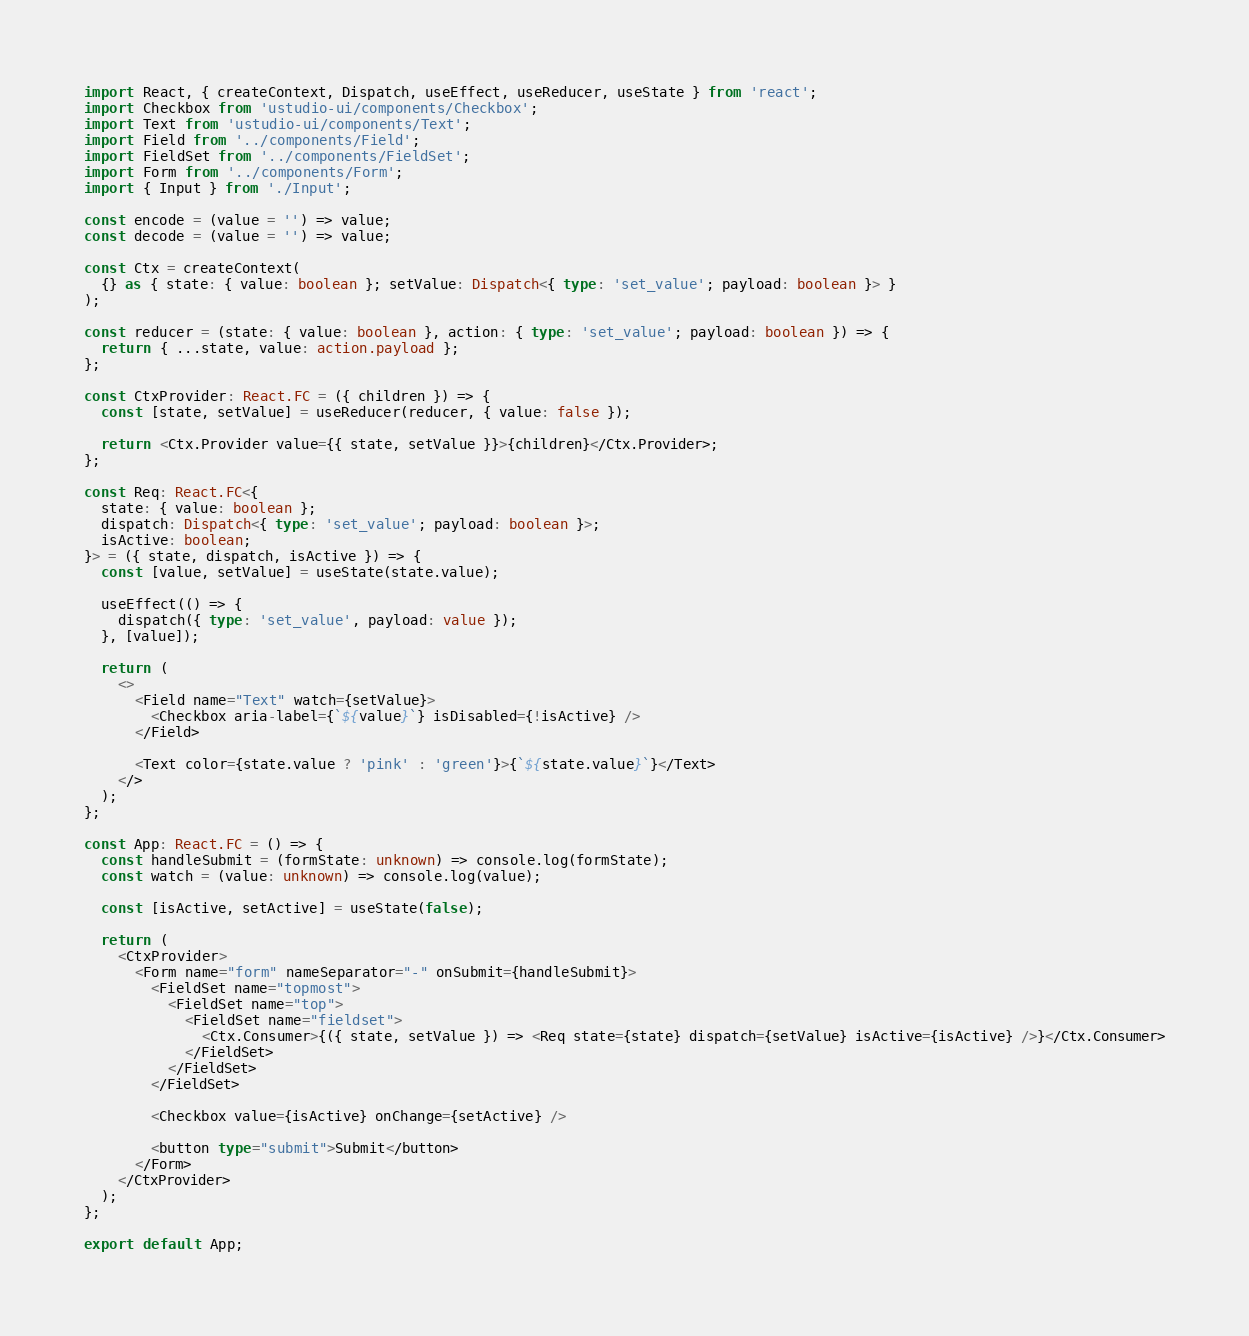Convert code to text. <code><loc_0><loc_0><loc_500><loc_500><_TypeScript_>import React, { createContext, Dispatch, useEffect, useReducer, useState } from 'react';
import Checkbox from 'ustudio-ui/components/Checkbox';
import Text from 'ustudio-ui/components/Text';
import Field from '../components/Field';
import FieldSet from '../components/FieldSet';
import Form from '../components/Form';
import { Input } from './Input';

const encode = (value = '') => value;
const decode = (value = '') => value;

const Ctx = createContext(
  {} as { state: { value: boolean }; setValue: Dispatch<{ type: 'set_value'; payload: boolean }> }
);

const reducer = (state: { value: boolean }, action: { type: 'set_value'; payload: boolean }) => {
  return { ...state, value: action.payload };
};

const CtxProvider: React.FC = ({ children }) => {
  const [state, setValue] = useReducer(reducer, { value: false });

  return <Ctx.Provider value={{ state, setValue }}>{children}</Ctx.Provider>;
};

const Req: React.FC<{
  state: { value: boolean };
  dispatch: Dispatch<{ type: 'set_value'; payload: boolean }>;
  isActive: boolean;
}> = ({ state, dispatch, isActive }) => {
  const [value, setValue] = useState(state.value);

  useEffect(() => {
    dispatch({ type: 'set_value', payload: value });
  }, [value]);

  return (
    <>
      <Field name="Text" watch={setValue}>
        <Checkbox aria-label={`${value}`} isDisabled={!isActive} />
      </Field>

      <Text color={state.value ? 'pink' : 'green'}>{`${state.value}`}</Text>
    </>
  );
};

const App: React.FC = () => {
  const handleSubmit = (formState: unknown) => console.log(formState);
  const watch = (value: unknown) => console.log(value);

  const [isActive, setActive] = useState(false);

  return (
    <CtxProvider>
      <Form name="form" nameSeparator="-" onSubmit={handleSubmit}>
        <FieldSet name="topmost">
          <FieldSet name="top">
            <FieldSet name="fieldset">
              <Ctx.Consumer>{({ state, setValue }) => <Req state={state} dispatch={setValue} isActive={isActive} />}</Ctx.Consumer>
            </FieldSet>
          </FieldSet>
        </FieldSet>

        <Checkbox value={isActive} onChange={setActive} />

        <button type="submit">Submit</button>
      </Form>
    </CtxProvider>
  );
};

export default App;
</code> 